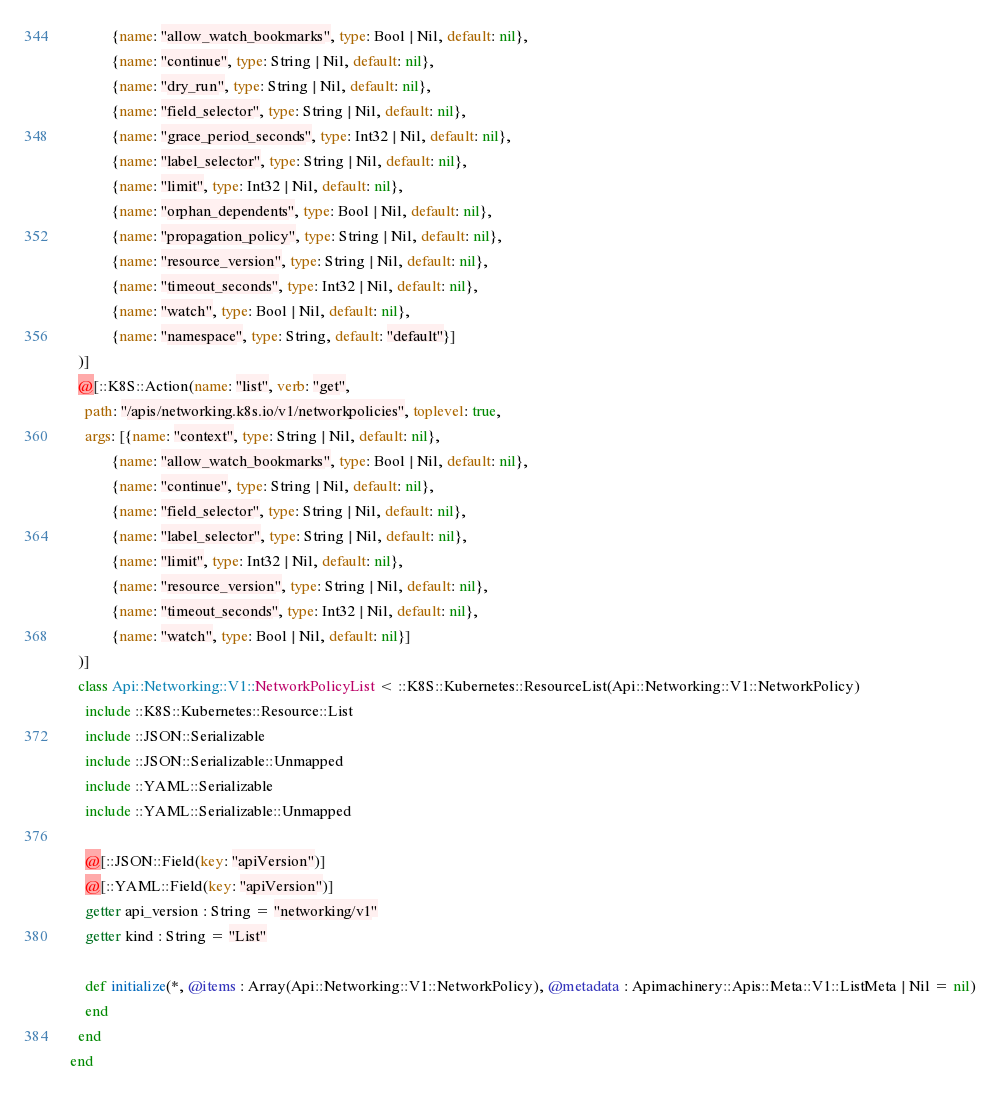Convert code to text. <code><loc_0><loc_0><loc_500><loc_500><_Crystal_>           {name: "allow_watch_bookmarks", type: Bool | Nil, default: nil},
           {name: "continue", type: String | Nil, default: nil},
           {name: "dry_run", type: String | Nil, default: nil},
           {name: "field_selector", type: String | Nil, default: nil},
           {name: "grace_period_seconds", type: Int32 | Nil, default: nil},
           {name: "label_selector", type: String | Nil, default: nil},
           {name: "limit", type: Int32 | Nil, default: nil},
           {name: "orphan_dependents", type: Bool | Nil, default: nil},
           {name: "propagation_policy", type: String | Nil, default: nil},
           {name: "resource_version", type: String | Nil, default: nil},
           {name: "timeout_seconds", type: Int32 | Nil, default: nil},
           {name: "watch", type: Bool | Nil, default: nil},
           {name: "namespace", type: String, default: "default"}]
  )]
  @[::K8S::Action(name: "list", verb: "get",
    path: "/apis/networking.k8s.io/v1/networkpolicies", toplevel: true,
    args: [{name: "context", type: String | Nil, default: nil},
           {name: "allow_watch_bookmarks", type: Bool | Nil, default: nil},
           {name: "continue", type: String | Nil, default: nil},
           {name: "field_selector", type: String | Nil, default: nil},
           {name: "label_selector", type: String | Nil, default: nil},
           {name: "limit", type: Int32 | Nil, default: nil},
           {name: "resource_version", type: String | Nil, default: nil},
           {name: "timeout_seconds", type: Int32 | Nil, default: nil},
           {name: "watch", type: Bool | Nil, default: nil}]
  )]
  class Api::Networking::V1::NetworkPolicyList < ::K8S::Kubernetes::ResourceList(Api::Networking::V1::NetworkPolicy)
    include ::K8S::Kubernetes::Resource::List
    include ::JSON::Serializable
    include ::JSON::Serializable::Unmapped
    include ::YAML::Serializable
    include ::YAML::Serializable::Unmapped

    @[::JSON::Field(key: "apiVersion")]
    @[::YAML::Field(key: "apiVersion")]
    getter api_version : String = "networking/v1"
    getter kind : String = "List"

    def initialize(*, @items : Array(Api::Networking::V1::NetworkPolicy), @metadata : Apimachinery::Apis::Meta::V1::ListMeta | Nil = nil)
    end
  end
end
</code> 